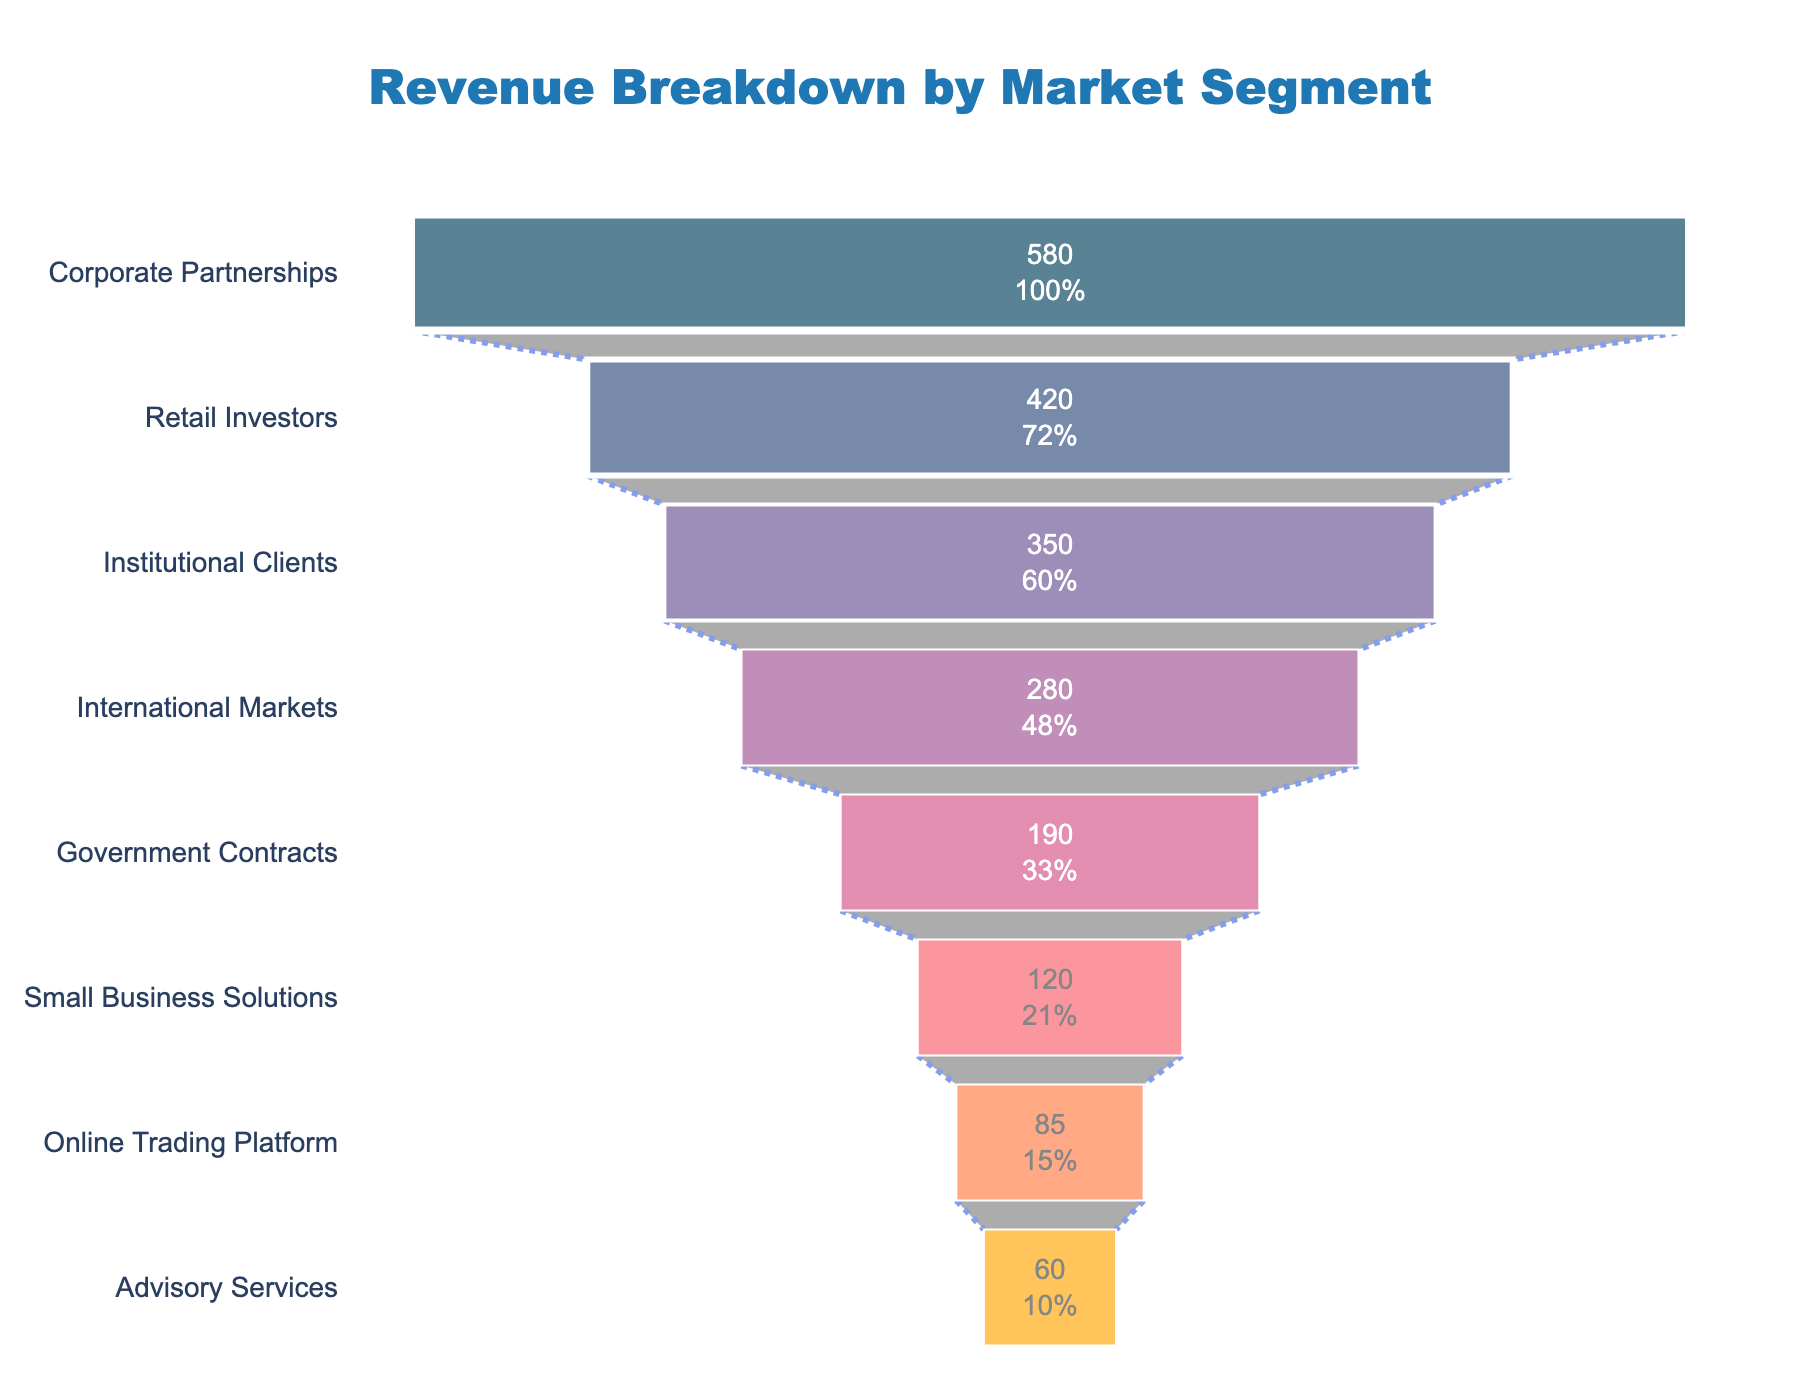What is the title of the funnel chart? The title is typically located at the top center of the funnel chart and is meant to summarize the subject of the chart.
Answer: "Revenue Breakdown by Market Segment" Which market segment contributes the highest revenue? The highest revenue segment will have the widest bar at the top of the funnel.
Answer: Corporate Partnerships What is the percentage contribution of the Retail Investors segment to the total revenue? Find the value for the Retail Investors segment and then divide it by the sum of all values, multiplied by 100 to get the percentage. The chart displays the percentage inside the segment.
Answer: 22.4% What is the combined revenue contribution of Institutional Clients and International Markets? Add the revenue values for both Institutional Clients and International Markets.
Answer: 630 million dollars How does the revenue from Government Contracts compare to Small Business Solutions? Compare the revenue values of Government Contracts and Small Business Solutions by subtracting the smaller value from the larger value.
Answer: Government Contracts contribute 70 million dollars more What is the smallest revenue-contributing segment? The smallest revenue-contributing segment will have the narrowest bar at the bottom of the funnel.
Answer: Advisory Services Rank the top three revenue-contributing segments. List the segments in order from the largest contributor to the smallest, based on the width of the bars in the funnel.
Answer: 1. Corporate Partnerships, 2. Retail Investors, 3. Institutional Clients What is the total revenue from all the market segments combined? Sum all the revenue values listed in the funnel chart.
Answer: 2085 million dollars How much more does the Online Trading Platform contribute compared to Advisory Services? Subtract the revenue value of Advisory Services from that of the Online Trading Platform.
Answer: 25 million dollars Which segment has a revenue between 100 million and 200 million dollars, and how much does it contribute exactly? Identify the bar whose value falls within the specified range, as per the visual data.
Answer: Government Contracts, 190 million dollars 